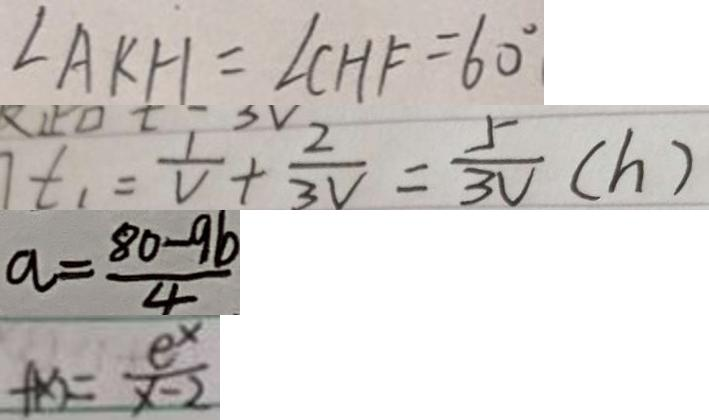<formula> <loc_0><loc_0><loc_500><loc_500>\angle A K H = \angle C H F = 6 0 ^ { \circ } 
 t _ { 1 } = \frac { 1 } { V } + \frac { 2 } { 3 V } = \frac { 5 } { 3 V } ( h ) 
 a = \frac { 8 0 - 9 b } { 4 } 
 f ( x ) = \frac { e ^ { x } } { x - 2 }</formula> 